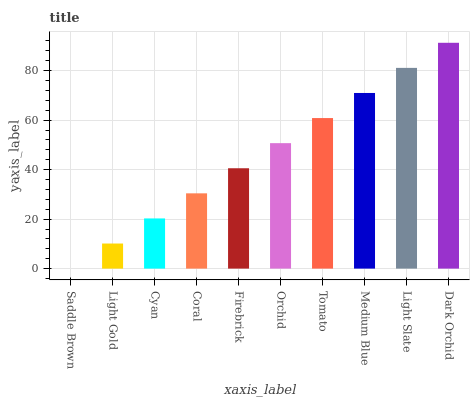Is Saddle Brown the minimum?
Answer yes or no. Yes. Is Dark Orchid the maximum?
Answer yes or no. Yes. Is Light Gold the minimum?
Answer yes or no. No. Is Light Gold the maximum?
Answer yes or no. No. Is Light Gold greater than Saddle Brown?
Answer yes or no. Yes. Is Saddle Brown less than Light Gold?
Answer yes or no. Yes. Is Saddle Brown greater than Light Gold?
Answer yes or no. No. Is Light Gold less than Saddle Brown?
Answer yes or no. No. Is Orchid the high median?
Answer yes or no. Yes. Is Firebrick the low median?
Answer yes or no. Yes. Is Tomato the high median?
Answer yes or no. No. Is Coral the low median?
Answer yes or no. No. 